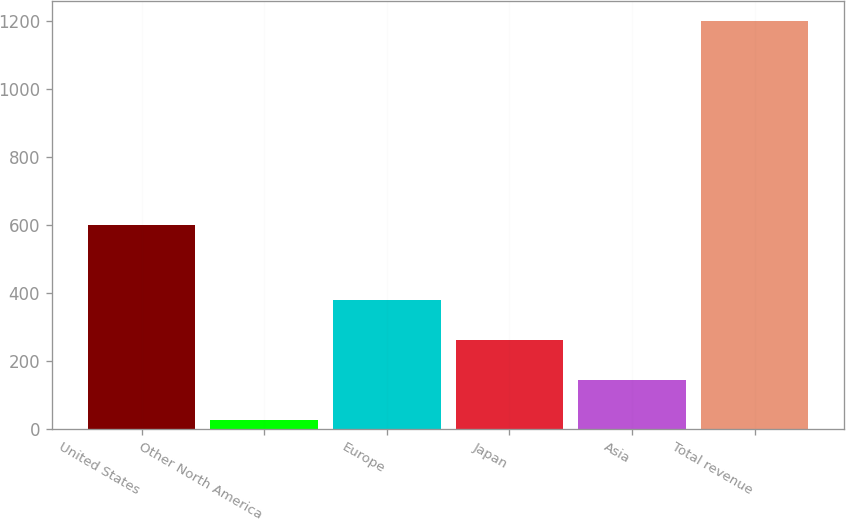Convert chart. <chart><loc_0><loc_0><loc_500><loc_500><bar_chart><fcel>United States<fcel>Other North America<fcel>Europe<fcel>Japan<fcel>Asia<fcel>Total revenue<nl><fcel>598.9<fcel>27<fcel>378.15<fcel>261.1<fcel>144.05<fcel>1197.5<nl></chart> 